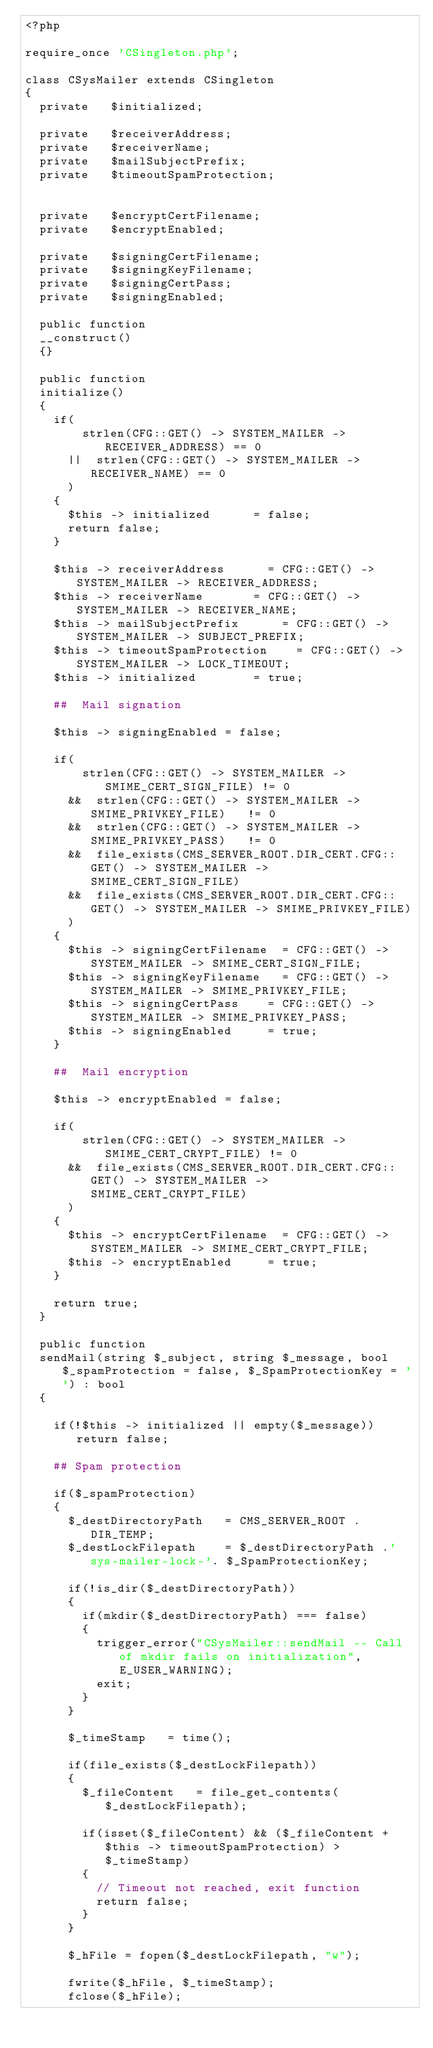<code> <loc_0><loc_0><loc_500><loc_500><_PHP_><?php

require_once 'CSingleton.php';

class	CSysMailer extends CSingleton
{
	private		$initialized;

	private		$receiverAddress;
	private		$receiverName;
	private		$mailSubjectPrefix;
	private		$timeoutSpamProtection;


	private		$encryptCertFilename;
	private		$encryptEnabled;

	private		$signingCertFilename;
	private		$signingKeyFilename;
	private		$signingCertPass;
	private		$signingEnabled;

	public function
	__construct()
	{}

	public function
	initialize()
	{		
		if(	   
				strlen(CFG::GET() -> SYSTEM_MAILER -> RECEIVER_ADDRESS) == 0
			||	strlen(CFG::GET() -> SYSTEM_MAILER -> RECEIVER_NAME) == 0
		  )	
		{
			$this -> initialized			= false;
			return false;
		}

		$this -> receiverAddress			= CFG::GET() -> SYSTEM_MAILER -> RECEIVER_ADDRESS;
		$this -> receiverName				= CFG::GET() -> SYSTEM_MAILER -> RECEIVER_NAME;
		$this -> mailSubjectPrefix			= CFG::GET() -> SYSTEM_MAILER -> SUBJECT_PREFIX;
		$this -> timeoutSpamProtection		= CFG::GET() -> SYSTEM_MAILER -> LOCK_TIMEOUT;
		$this -> initialized				= true;

		##	Mail signation

		$this -> signingEnabled = false;

		if(	   
				strlen(CFG::GET() -> SYSTEM_MAILER -> SMIME_CERT_SIGN_FILE) != 0
			&&	strlen(CFG::GET() -> SYSTEM_MAILER -> SMIME_PRIVKEY_FILE)   != 0
			&&	strlen(CFG::GET() -> SYSTEM_MAILER -> SMIME_PRIVKEY_PASS)   != 0
			&&	file_exists(CMS_SERVER_ROOT.DIR_CERT.CFG::GET() -> SYSTEM_MAILER -> SMIME_CERT_SIGN_FILE)
			&&	file_exists(CMS_SERVER_ROOT.DIR_CERT.CFG::GET() -> SYSTEM_MAILER -> SMIME_PRIVKEY_FILE)
		  )	
		{
			$this -> signingCertFilename 	= CFG::GET() -> SYSTEM_MAILER -> SMIME_CERT_SIGN_FILE;
			$this -> signingKeyFilename 	= CFG::GET() -> SYSTEM_MAILER -> SMIME_PRIVKEY_FILE;
			$this -> signingCertPass 		= CFG::GET() -> SYSTEM_MAILER -> SMIME_PRIVKEY_PASS;
			$this -> signingEnabled 		= true;
		}	

		##	Mail encryption

		$this -> encryptEnabled = false;
		
		if(	   
				strlen(CFG::GET() -> SYSTEM_MAILER -> SMIME_CERT_CRYPT_FILE) != 0
			&&	file_exists(CMS_SERVER_ROOT.DIR_CERT.CFG::GET() -> SYSTEM_MAILER -> SMIME_CERT_CRYPT_FILE)
		  )	
		{
			$this -> encryptCertFilename 	= CFG::GET() -> SYSTEM_MAILER -> SMIME_CERT_CRYPT_FILE;
			$this -> encryptEnabled 		= true;
		}

		return true;
	}

	public function
	sendMail(string $_subject, string $_message, bool $_spamProtection = false, $_SpamProtectionKey = '') : bool
	{

		if(!$this -> initialized || empty($_message)) return false;

		## Spam protection

		if($_spamProtection)
		{
			$_destDirectoryPath		= CMS_SERVER_ROOT . DIR_TEMP;
			$_destLockFilepath		= $_destDirectoryPath .'sys-mailer-lock-'. $_SpamProtectionKey;

			if(!is_dir($_destDirectoryPath))
			{
				if(mkdir($_destDirectoryPath) === false)
				{
					trigger_error("CSysMailer::sendMail -- Call of mkdir fails on initialization",E_USER_WARNING);
					exit;
				}
			}

			$_timeStamp		= time();

			if(file_exists($_destLockFilepath))
			{
				$_fileContent 	= file_get_contents($_destLockFilepath);		

				if(isset($_fileContent) && ($_fileContent + $this -> timeoutSpamProtection) > $_timeStamp)
				{
					// Timeout not reached, exit function
					return false;
				}
			}

			$_hFile = fopen($_destLockFilepath, "w");	

			fwrite($_hFile, $_timeStamp);
			fclose($_hFile);</code> 